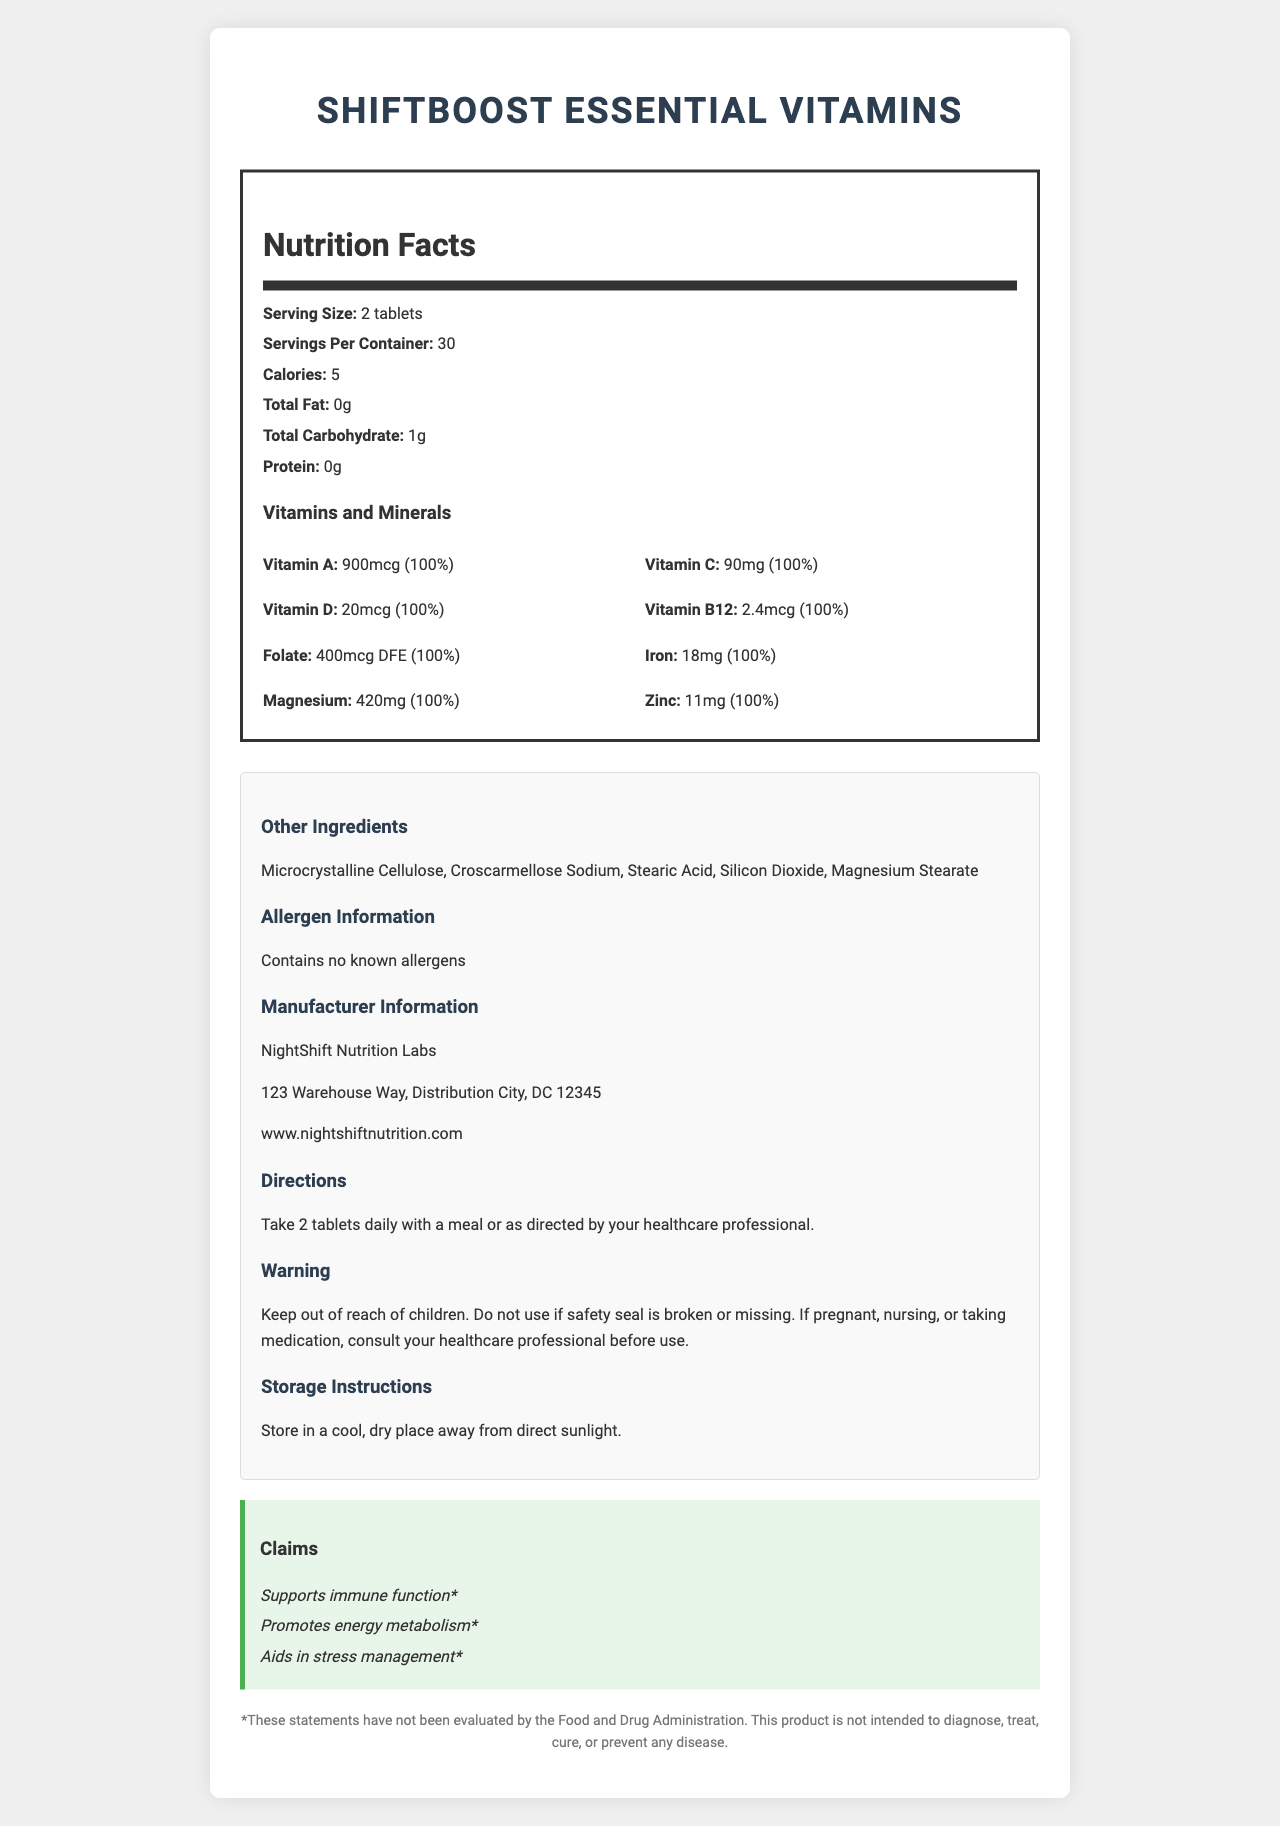what is the name of the product? The name of the product is displayed prominently at the top of the document.
Answer: ShiftBoost Essential Vitamins how many calories are there per serving? The nutrition facts section of the document states that there are 5 calories per serving.
Answer: 5 which vitamin has a daily value of 100% and an amount of 90mg? The nutrition facts section lists Vitamin C with an amount of 90mg and a daily value of 100%.
Answer: Vitamin C what is the serving size? The nutrition facts section indicates that the serving size is 2 tablets.
Answer: 2 tablets what is the address of the manufacturer? The manufacturer information section lists the address as 123 Warehouse Way, Distribution City, DC 12345.
Answer: 123 Warehouse Way, Distribution City, DC 12345 how should the product be stored? The storage instructions section advises to store the product in a cool, dry place away from direct sunlight.
Answer: Store in a cool, dry place away from direct sunlight. how many servings are there per container? The nutrition facts section mentions that there are 30 servings per container.
Answer: 30 which of the following vitamins is included in the product in an amount of 20mcg? A. Vitamin A B. Vitamin D C. Vitamin B12 D. Folate The nutrition facts section lists Vitamin D with an amount of 20mcg.
Answer: B which ingredient is not found in the "Other Ingredients" list? A. Microcrystalline Cellulose B. Croscarmellose Sodium C. Silicon Dioxide D. Dairy The other ingredients section lists all except Dairy.
Answer: D should pregnant individuals consult a healthcare professional before using this product? The warning statement advises that if pregnant, nursing, or taking medication, one should consult a healthcare professional before use.
Answer: Yes is there any information about the product's potential to cure diseases? The disclaimer statement clearly mentions that the product is not intended to diagnose, treat, cure, or prevent any disease.
Answer: No summarize the information provided in the document. The document provides comprehensive information about the product, including nutritional content, ingredients, manufacturer details, directions for use, and warnings, supporting informed usage.
Answer: The document is a detailed nutrition facts label for ShiftBoost Essential Vitamins, a supplement designed for workers with irregular eating schedules. It includes information on serving size and servings per container, lists the vitamins and minerals with their amounts and daily values, contains a list of other ingredients and allergen information, and provides manufacturer details, usage directions, warnings, storage instructions, and marketing claims. A disclaimer notes that the product is not meant to diagnose or treat diseases. what is the equivalent amount of Folate in mcg DFE? The nutrition facts section specifies the amount of Folate as 400mcg DFE.
Answer: 400mcg DFE does the product support immune function, according to the claims? The claim statements section states that the product supports immune function.
Answer: Yes can the efficacy of this product's claims be fully validated based on the document? The disclaimer notes that the statements have not been evaluated by the Food and Drug Administration, indicating that the claims cannot be fully validated based on the document alone.
Answer: No who is the manufacturer of the product? The manufacturer information section names NightShift Nutrition Labs as the manufacturer.
Answer: NightShift Nutrition Labs 